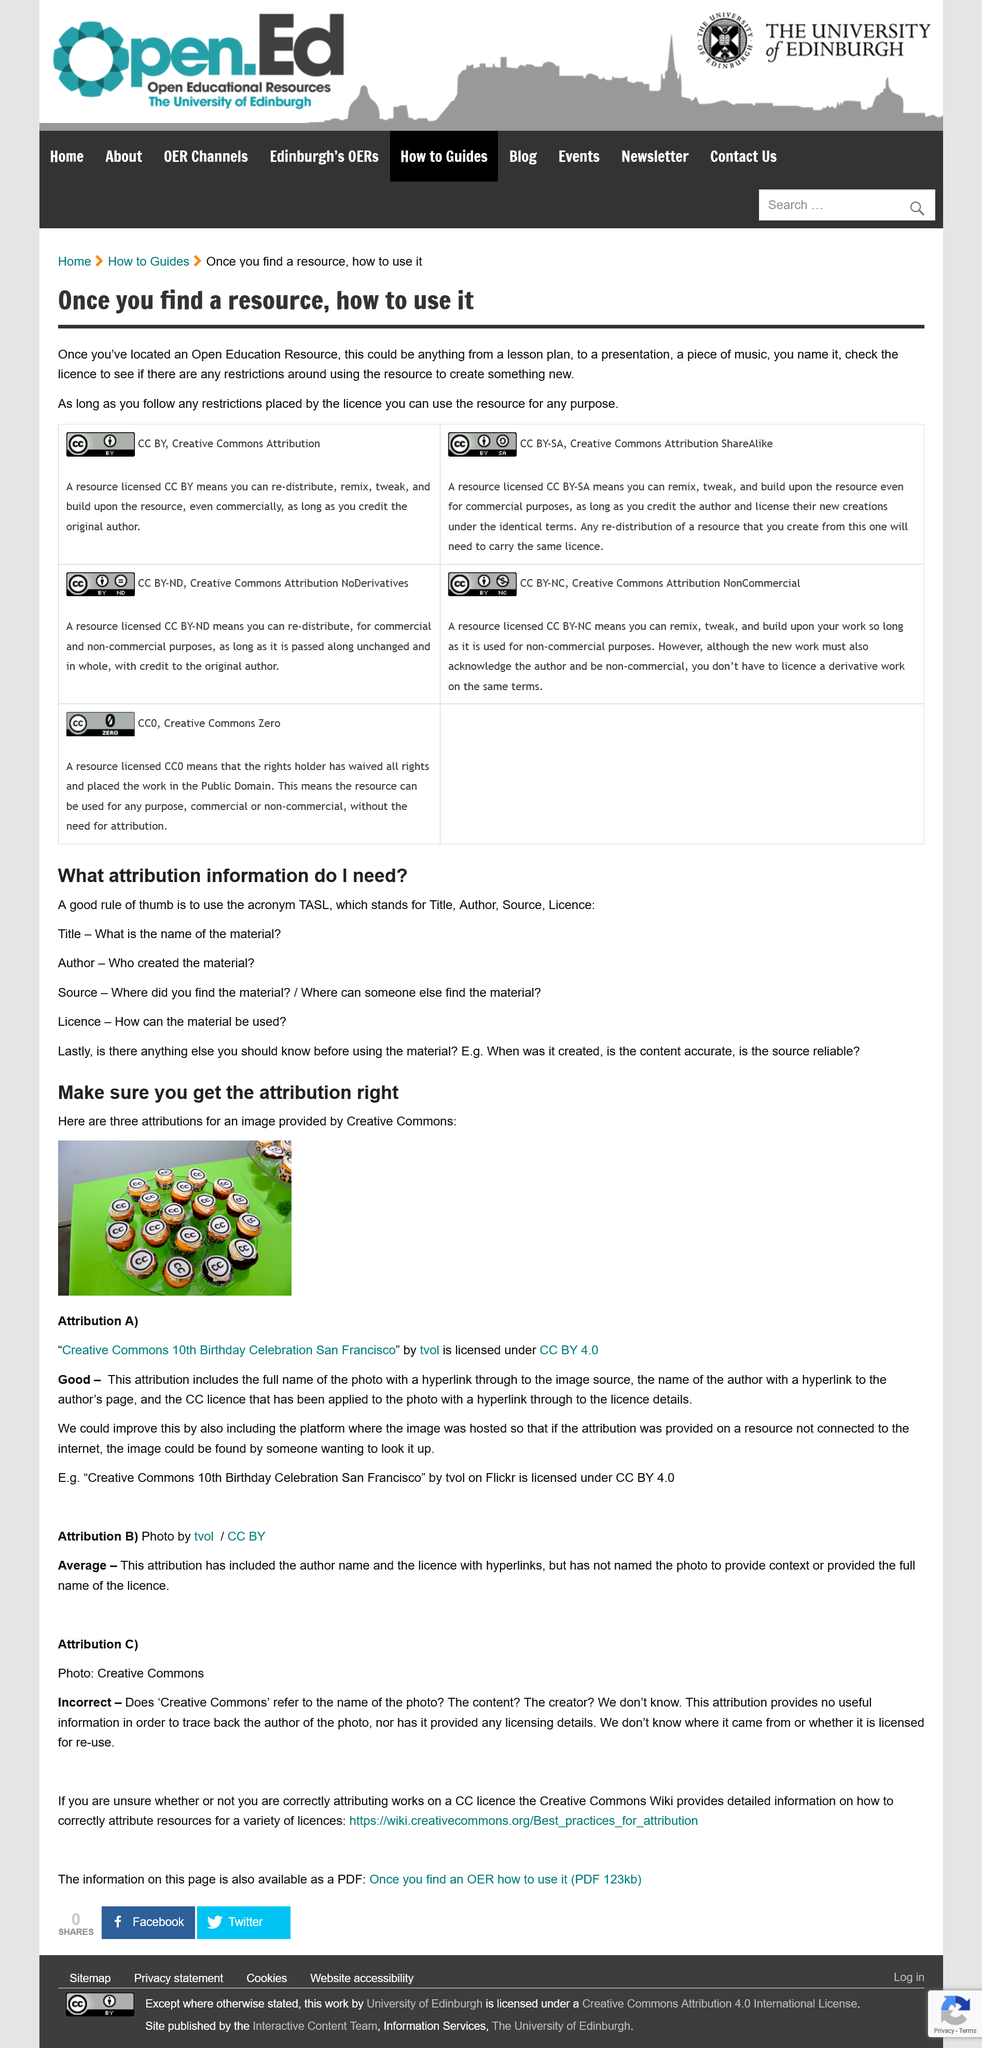Identify some key points in this picture. Attribution B is rated as average. Attribution A rated is considered to be of good quality. You must ensure that the attribution is correct. 